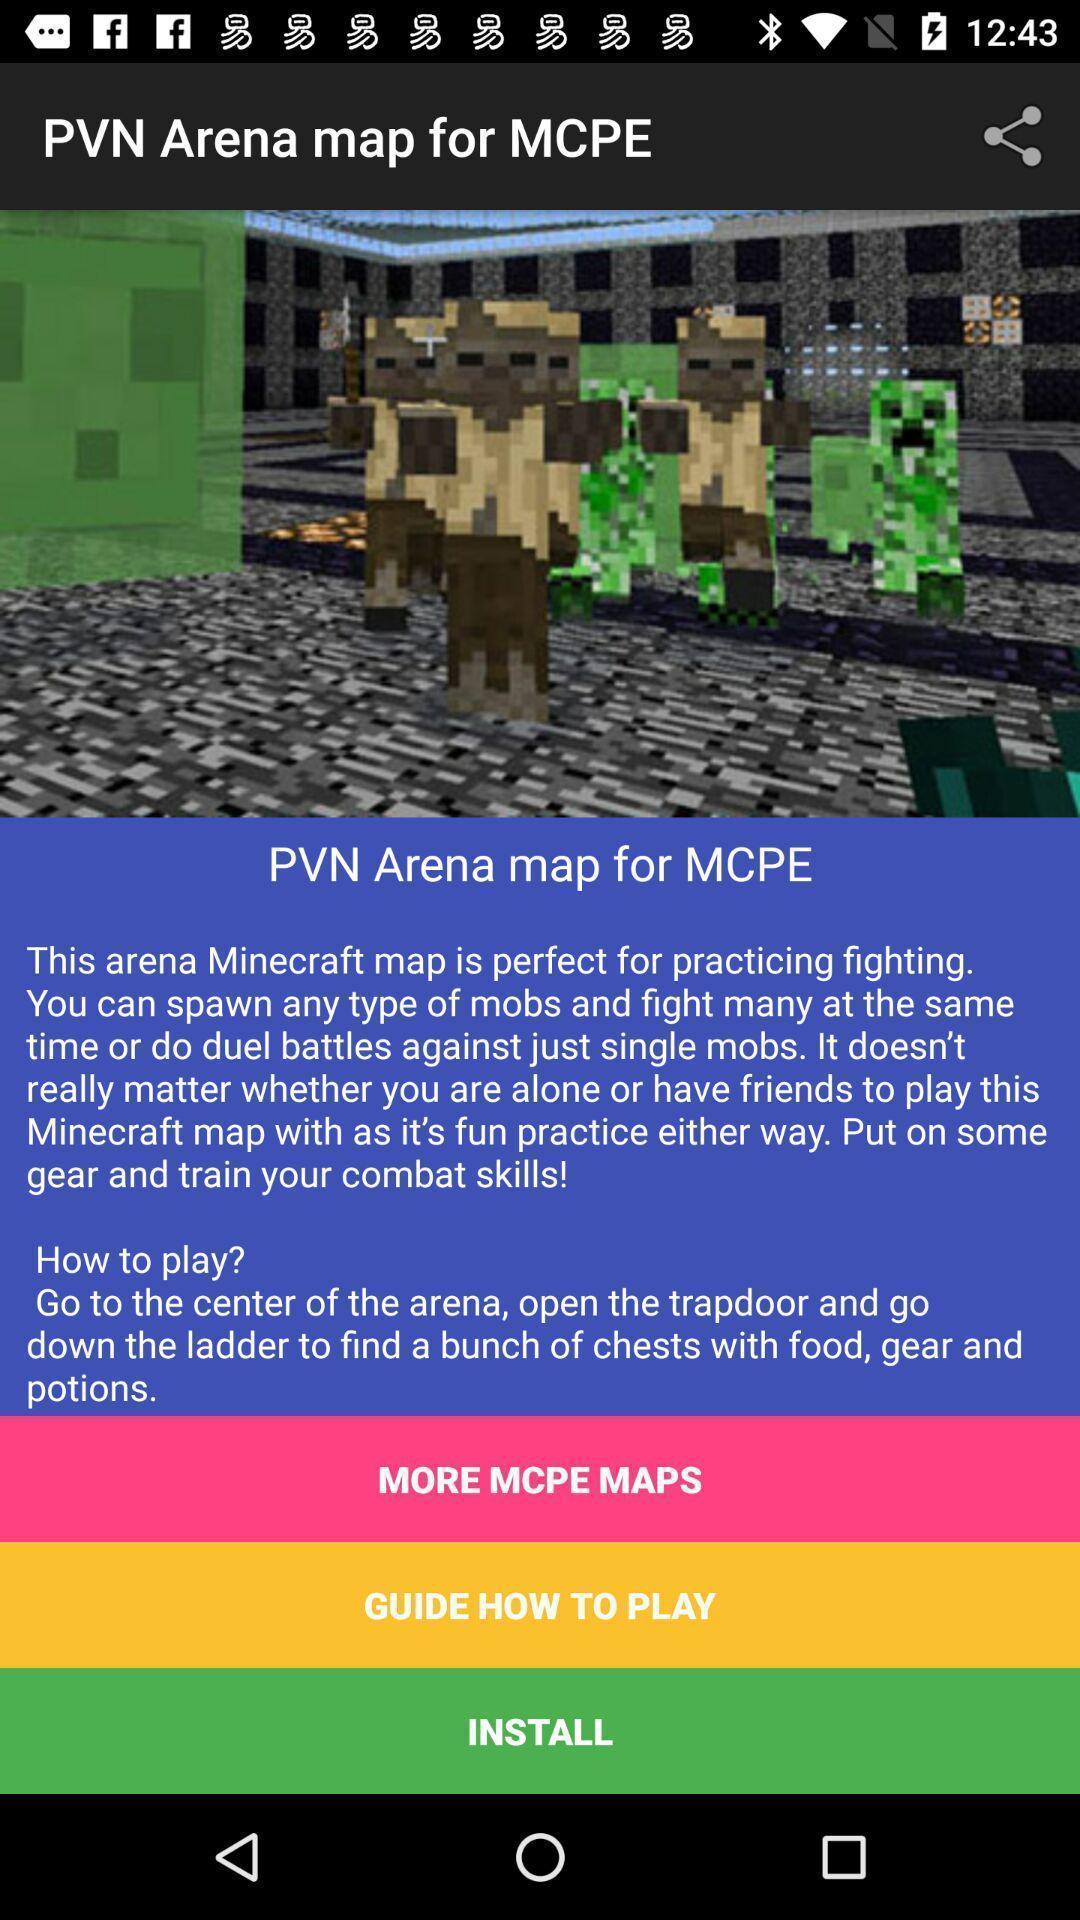Describe the content in this image. Screen displaying information about a gaming application. 